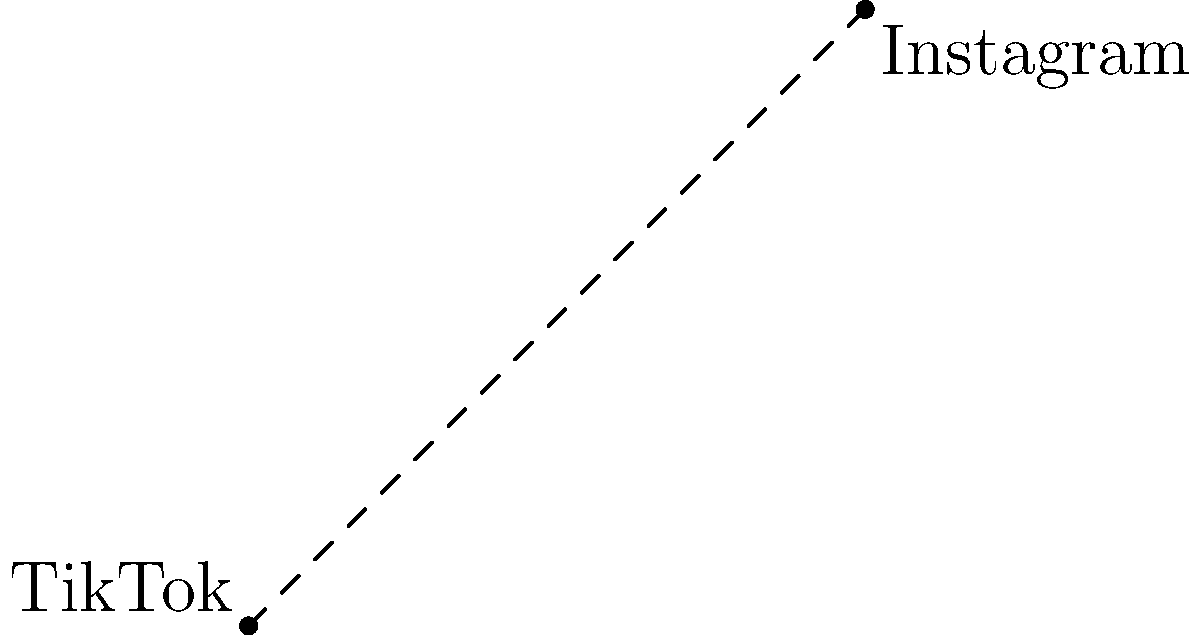Yo, check it. The TikTok icon is chillin' at (1,2) and the Insta icon's at (5,6) on this grid. How far apart are these apps on your screen? Round to two decimal places cuz who cares about the rest. Aight, let's break this down:

1) We're dealing with the distance formula here. It's basically Pythagoras but with coordinates:
   $$d = \sqrt{(x_2-x_1)^2 + (y_2-y_1)^2}$$

2) We've got:
   TikTok at $(x_1,y_1) = (1,2)$
   Instagram at $(x_2,y_2) = (5,6)$

3) Let's plug these into the formula:
   $$d = \sqrt{(5-1)^2 + (6-2)^2}$$

4) Simplify inside the parentheses:
   $$d = \sqrt{4^2 + 4^2}$$

5) Calculate the squares:
   $$d = \sqrt{16 + 16}$$

6) Add inside the square root:
   $$d = \sqrt{32}$$

7) Simplify the square root:
   $$d = 4\sqrt{2} \approx 5.66$$

8) Rounding to two decimal places:
   $$d \approx 5.66$$

So yeah, that's the distance between your social media icons or whatever.
Answer: 5.66 